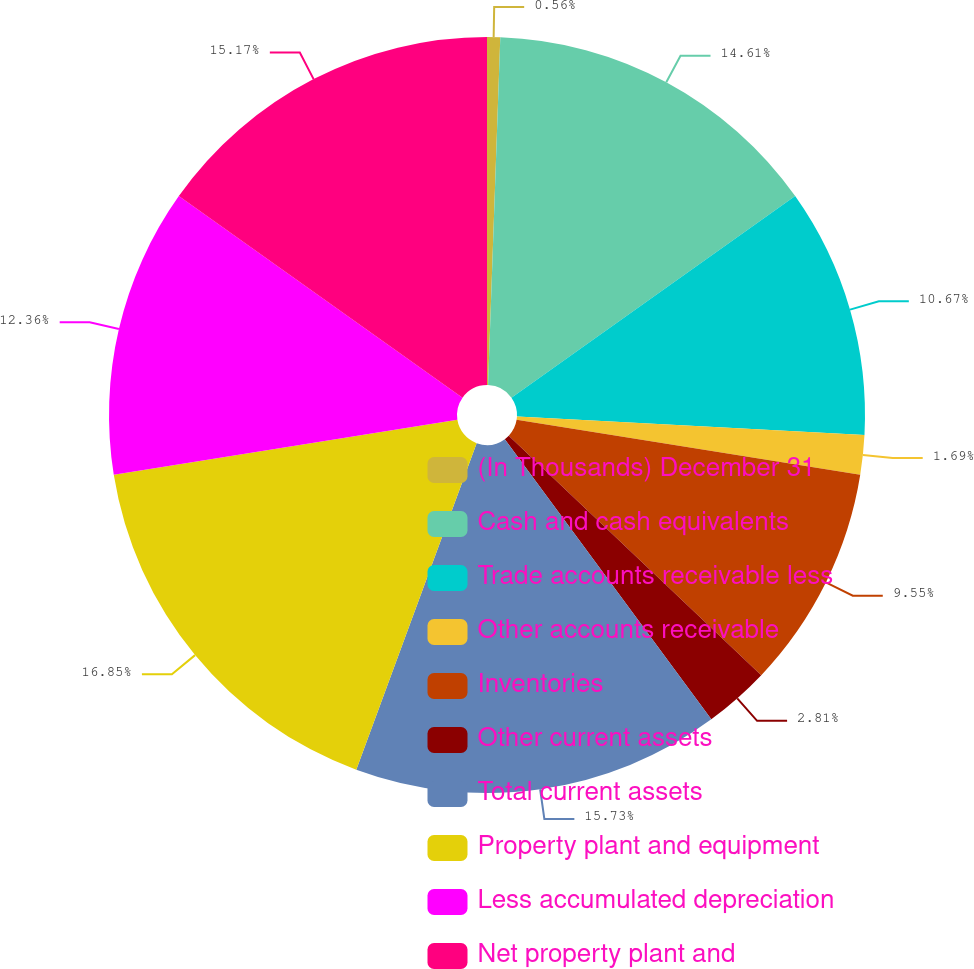<chart> <loc_0><loc_0><loc_500><loc_500><pie_chart><fcel>(In Thousands) December 31<fcel>Cash and cash equivalents<fcel>Trade accounts receivable less<fcel>Other accounts receivable<fcel>Inventories<fcel>Other current assets<fcel>Total current assets<fcel>Property plant and equipment<fcel>Less accumulated depreciation<fcel>Net property plant and<nl><fcel>0.56%<fcel>14.61%<fcel>10.67%<fcel>1.69%<fcel>9.55%<fcel>2.81%<fcel>15.73%<fcel>16.85%<fcel>12.36%<fcel>15.17%<nl></chart> 